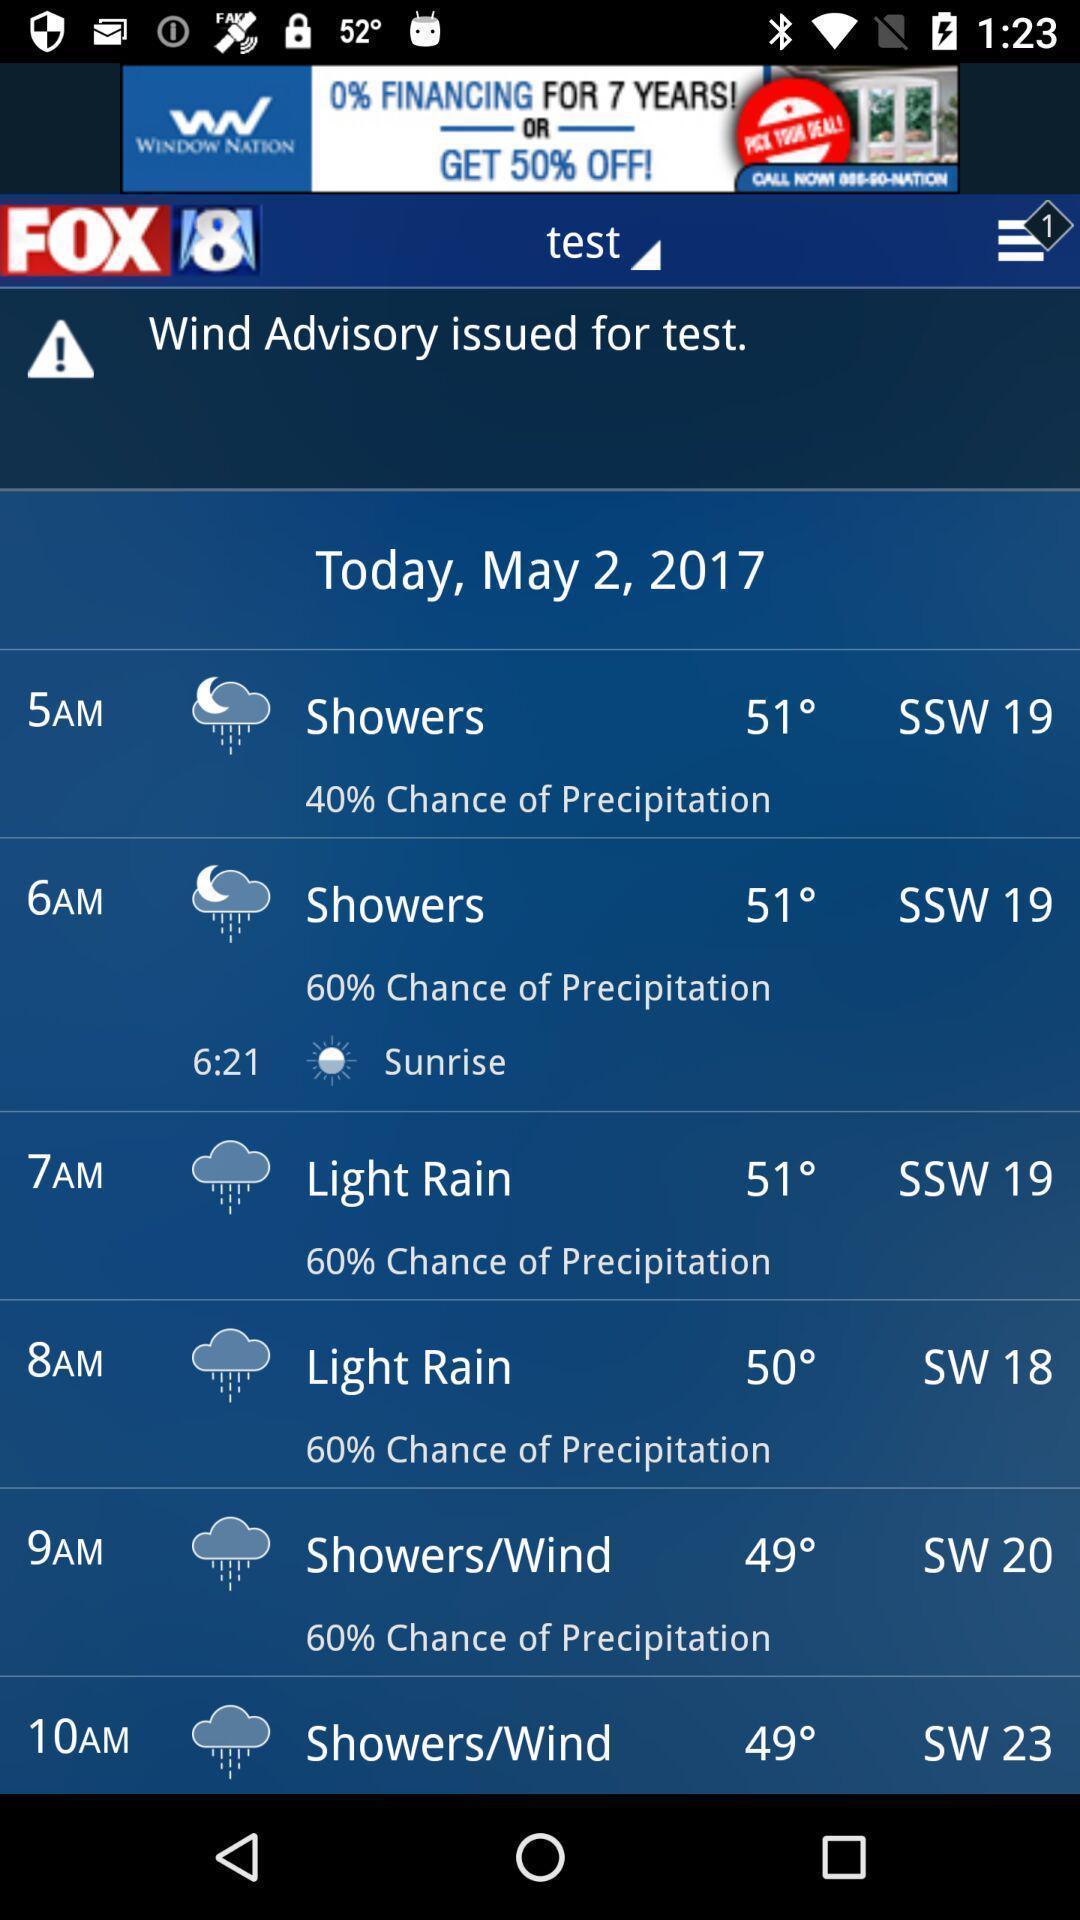Provide a description of this screenshot. Window displaying about weather forecast. 